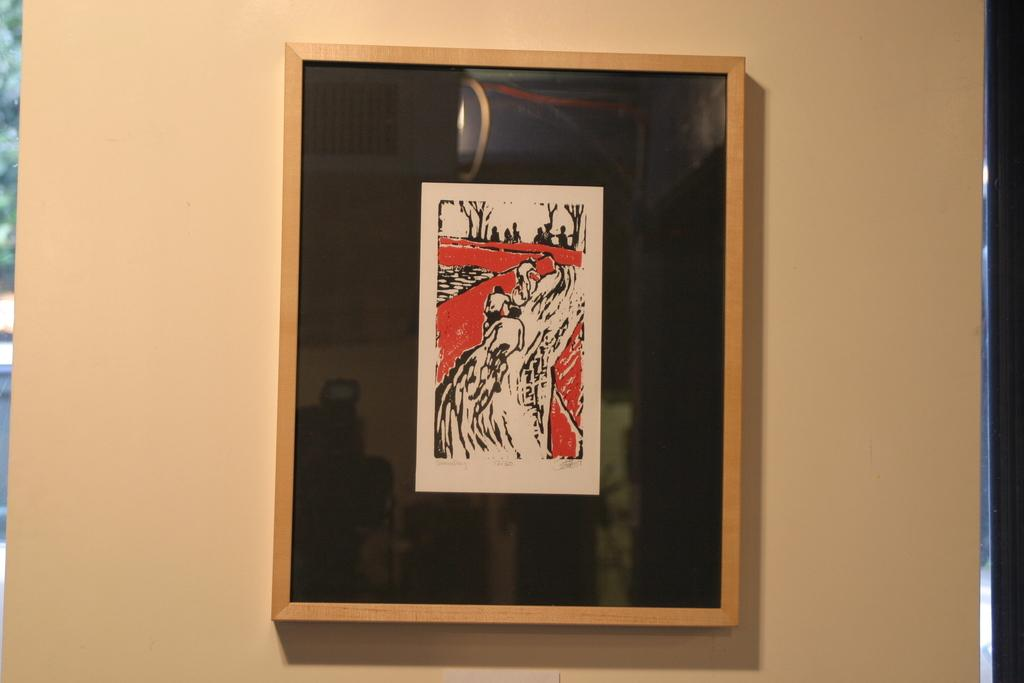What is depicted on the paper in the image? There is a sketch on a paper in the image. What are the three persons in the image doing? The three persons are riding bicycles in the image. What type of zephyr can be seen blowing the branch in the image? There is no zephyr or branch present in the image. What is the extent of the destruction caused by the persons riding bicycles in the image? There is no destruction depicted in the image; the three persons are simply riding bicycles. 